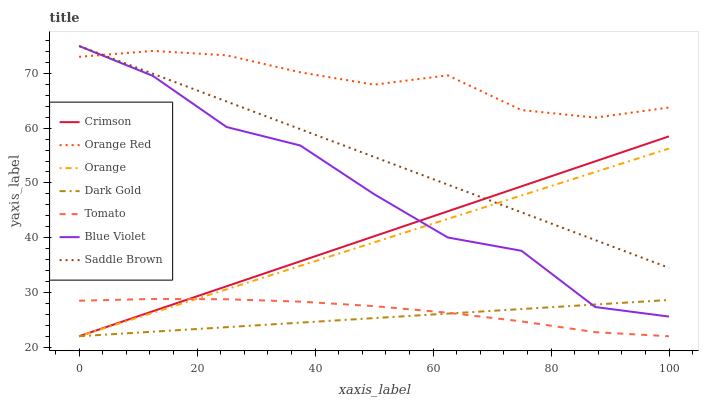Does Dark Gold have the minimum area under the curve?
Answer yes or no. Yes. Does Orange Red have the maximum area under the curve?
Answer yes or no. Yes. Does Saddle Brown have the minimum area under the curve?
Answer yes or no. No. Does Saddle Brown have the maximum area under the curve?
Answer yes or no. No. Is Dark Gold the smoothest?
Answer yes or no. Yes. Is Blue Violet the roughest?
Answer yes or no. Yes. Is Saddle Brown the smoothest?
Answer yes or no. No. Is Saddle Brown the roughest?
Answer yes or no. No. Does Tomato have the lowest value?
Answer yes or no. Yes. Does Saddle Brown have the lowest value?
Answer yes or no. No. Does Blue Violet have the highest value?
Answer yes or no. Yes. Does Dark Gold have the highest value?
Answer yes or no. No. Is Dark Gold less than Orange Red?
Answer yes or no. Yes. Is Saddle Brown greater than Dark Gold?
Answer yes or no. Yes. Does Crimson intersect Blue Violet?
Answer yes or no. Yes. Is Crimson less than Blue Violet?
Answer yes or no. No. Is Crimson greater than Blue Violet?
Answer yes or no. No. Does Dark Gold intersect Orange Red?
Answer yes or no. No. 